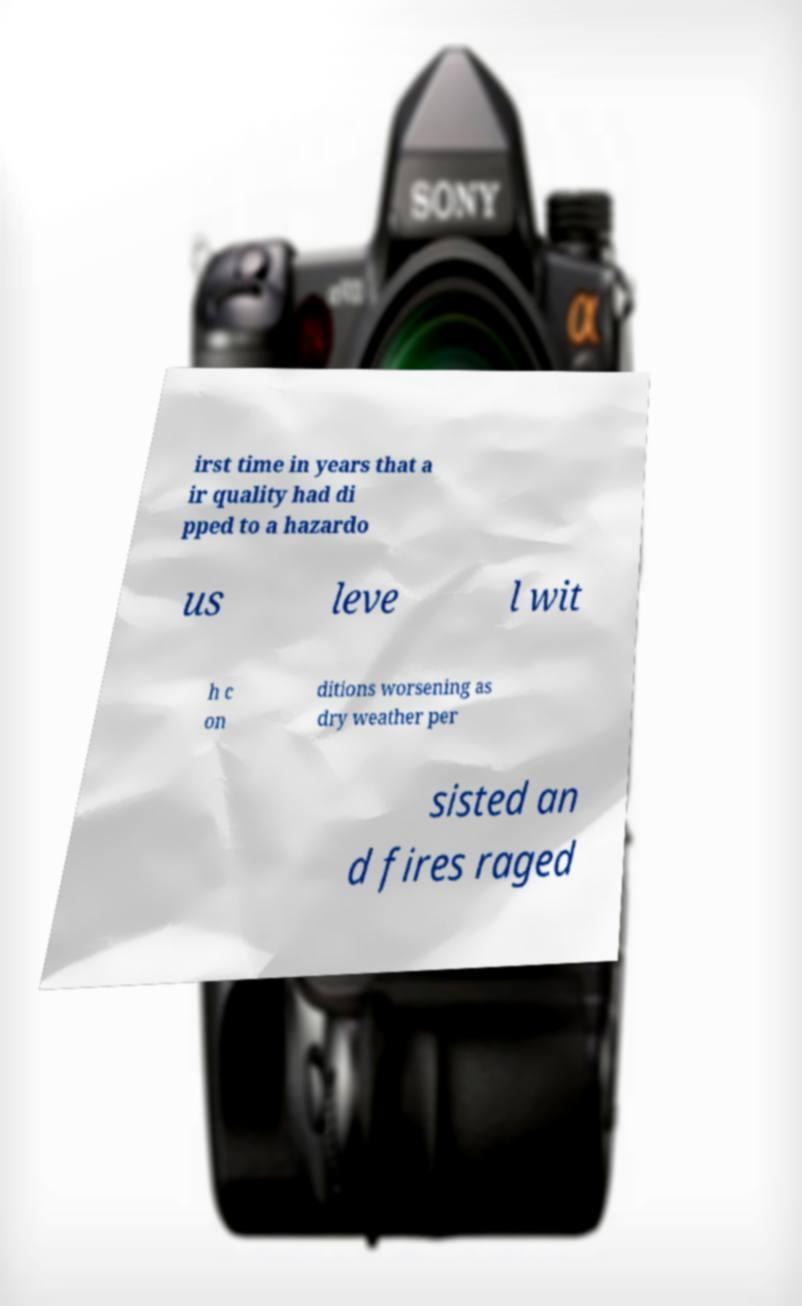Can you accurately transcribe the text from the provided image for me? irst time in years that a ir quality had di pped to a hazardo us leve l wit h c on ditions worsening as dry weather per sisted an d fires raged 